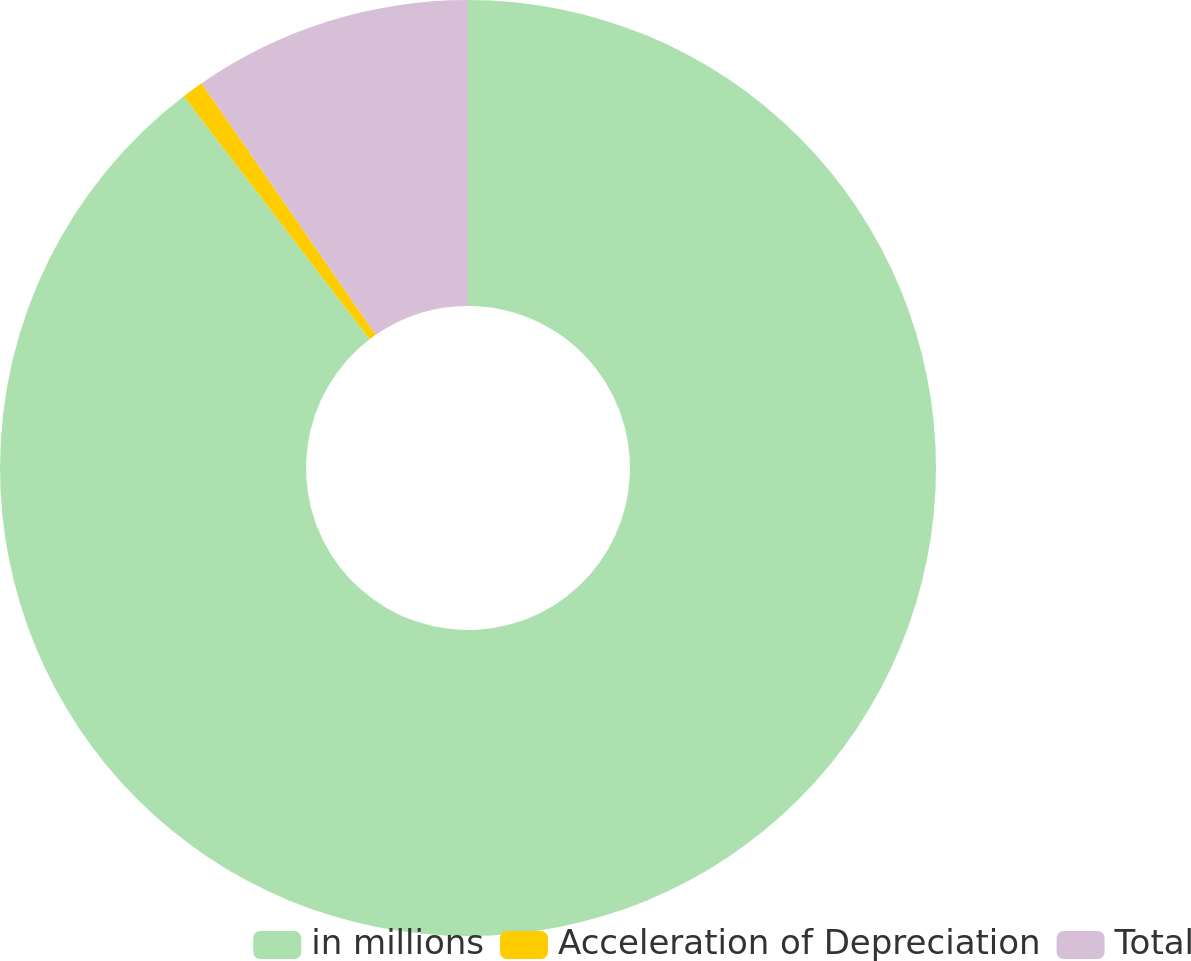Convert chart. <chart><loc_0><loc_0><loc_500><loc_500><pie_chart><fcel>in millions<fcel>Acceleration of Depreciation<fcel>Total<nl><fcel>89.61%<fcel>0.75%<fcel>9.64%<nl></chart> 